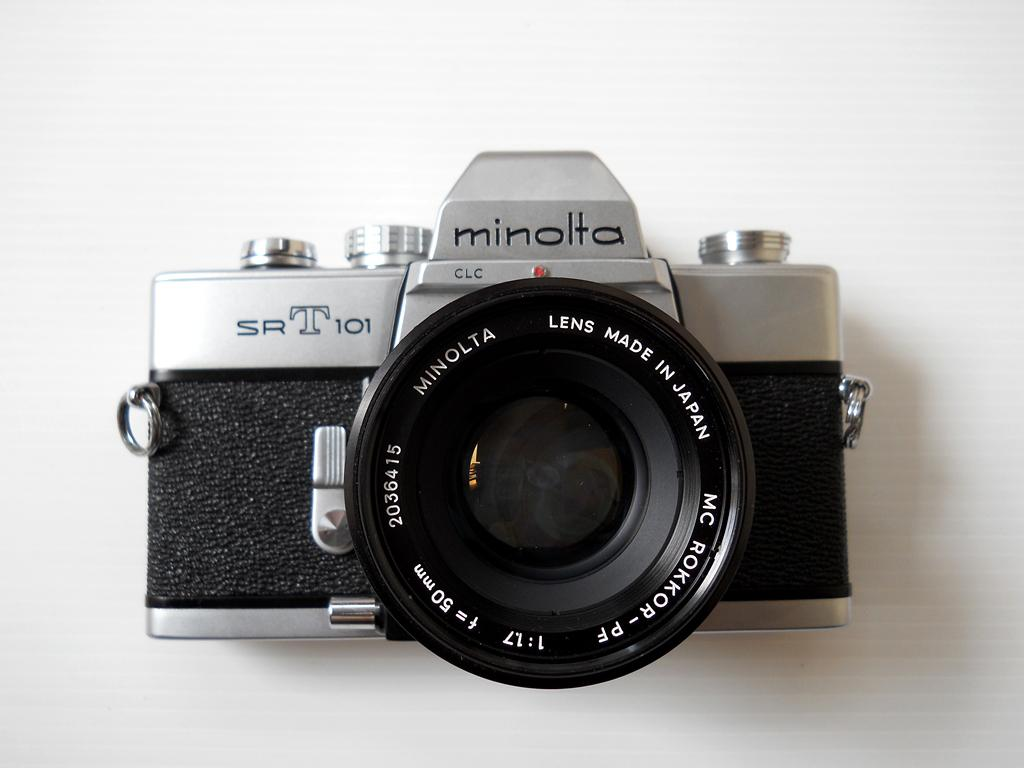What object is the main focus of the image? There is a camera in the image. What can be seen on the camera? The camera has text on it. What colors are present on the camera? The camera is in black and silver color. What type of fruit is being served on the camera in the image? There is no fruit present in the image, and the camera is not serving any food. What kind of wax is used to polish the camera in the image? There is no mention of wax or any polishing activity in the image; the camera's appearance is described by its color scheme. 